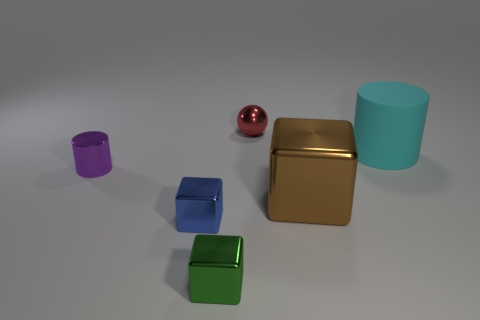There is another large shiny thing that is the same shape as the blue metal object; what color is it? The large shiny object that shares the same cuboid shape as the blue one is colored gold. 